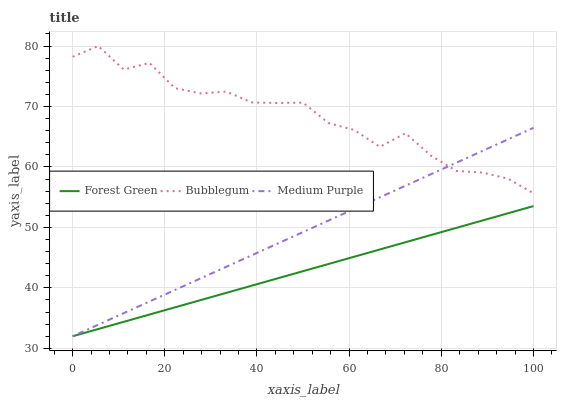Does Forest Green have the minimum area under the curve?
Answer yes or no. Yes. Does Bubblegum have the maximum area under the curve?
Answer yes or no. Yes. Does Bubblegum have the minimum area under the curve?
Answer yes or no. No. Does Forest Green have the maximum area under the curve?
Answer yes or no. No. Is Medium Purple the smoothest?
Answer yes or no. Yes. Is Bubblegum the roughest?
Answer yes or no. Yes. Is Forest Green the smoothest?
Answer yes or no. No. Is Forest Green the roughest?
Answer yes or no. No. Does Medium Purple have the lowest value?
Answer yes or no. Yes. Does Bubblegum have the lowest value?
Answer yes or no. No. Does Bubblegum have the highest value?
Answer yes or no. Yes. Does Forest Green have the highest value?
Answer yes or no. No. Is Forest Green less than Bubblegum?
Answer yes or no. Yes. Is Bubblegum greater than Forest Green?
Answer yes or no. Yes. Does Medium Purple intersect Forest Green?
Answer yes or no. Yes. Is Medium Purple less than Forest Green?
Answer yes or no. No. Is Medium Purple greater than Forest Green?
Answer yes or no. No. Does Forest Green intersect Bubblegum?
Answer yes or no. No. 